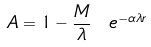<formula> <loc_0><loc_0><loc_500><loc_500>A = 1 - \frac { M } { \lambda } \ e ^ { - \alpha \lambda r }</formula> 